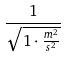Convert formula to latex. <formula><loc_0><loc_0><loc_500><loc_500>\frac { 1 } { \sqrt { 1 \cdot \frac { m ^ { 2 } } { s ^ { 2 } } } }</formula> 